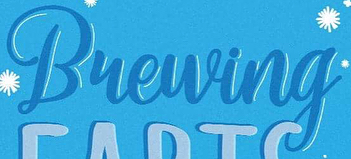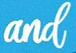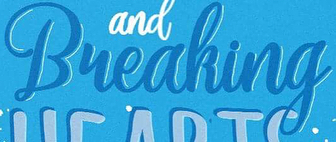What words can you see in these images in sequence, separated by a semicolon? Bueuing; and; Bueaking 